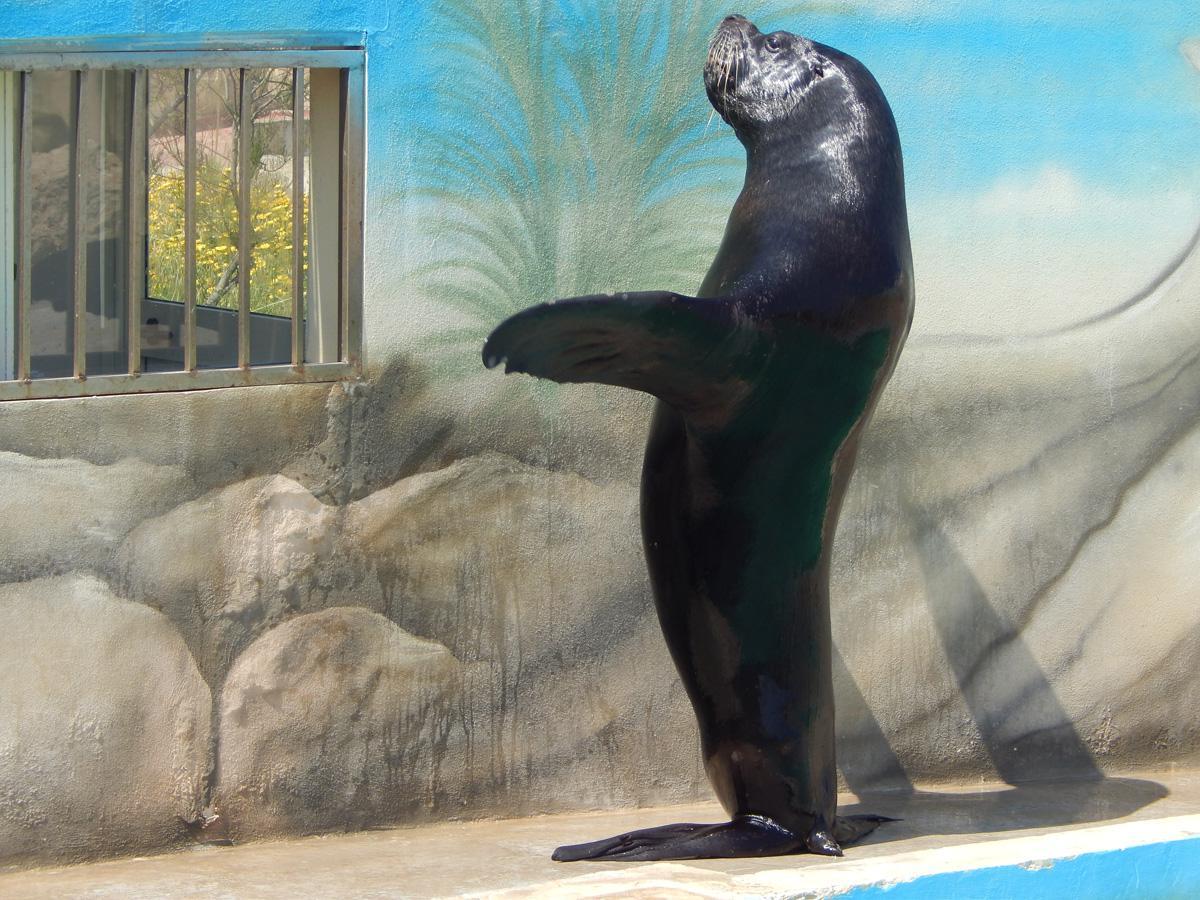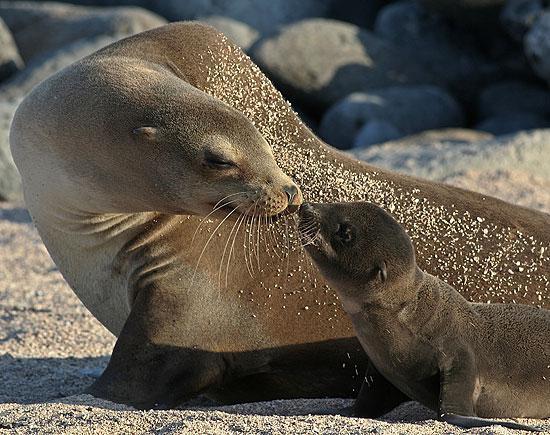The first image is the image on the left, the second image is the image on the right. Analyze the images presented: Is the assertion "There is one trainer working with a seal in the image on the left." valid? Answer yes or no. No. The first image is the image on the left, the second image is the image on the right. Considering the images on both sides, is "A man is interacting with one of the seals." valid? Answer yes or no. No. 